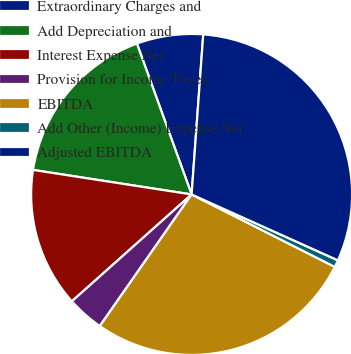Convert chart to OTSL. <chart><loc_0><loc_0><loc_500><loc_500><pie_chart><fcel>Extraordinary Charges and<fcel>Add Depreciation and<fcel>Interest Expense Net<fcel>Provision for Income Taxes<fcel>EBITDA<fcel>Add Other (Income) Expense Net<fcel>Adjusted EBITDA<nl><fcel>6.69%<fcel>17.02%<fcel>14.04%<fcel>3.71%<fcel>27.24%<fcel>0.72%<fcel>30.58%<nl></chart> 